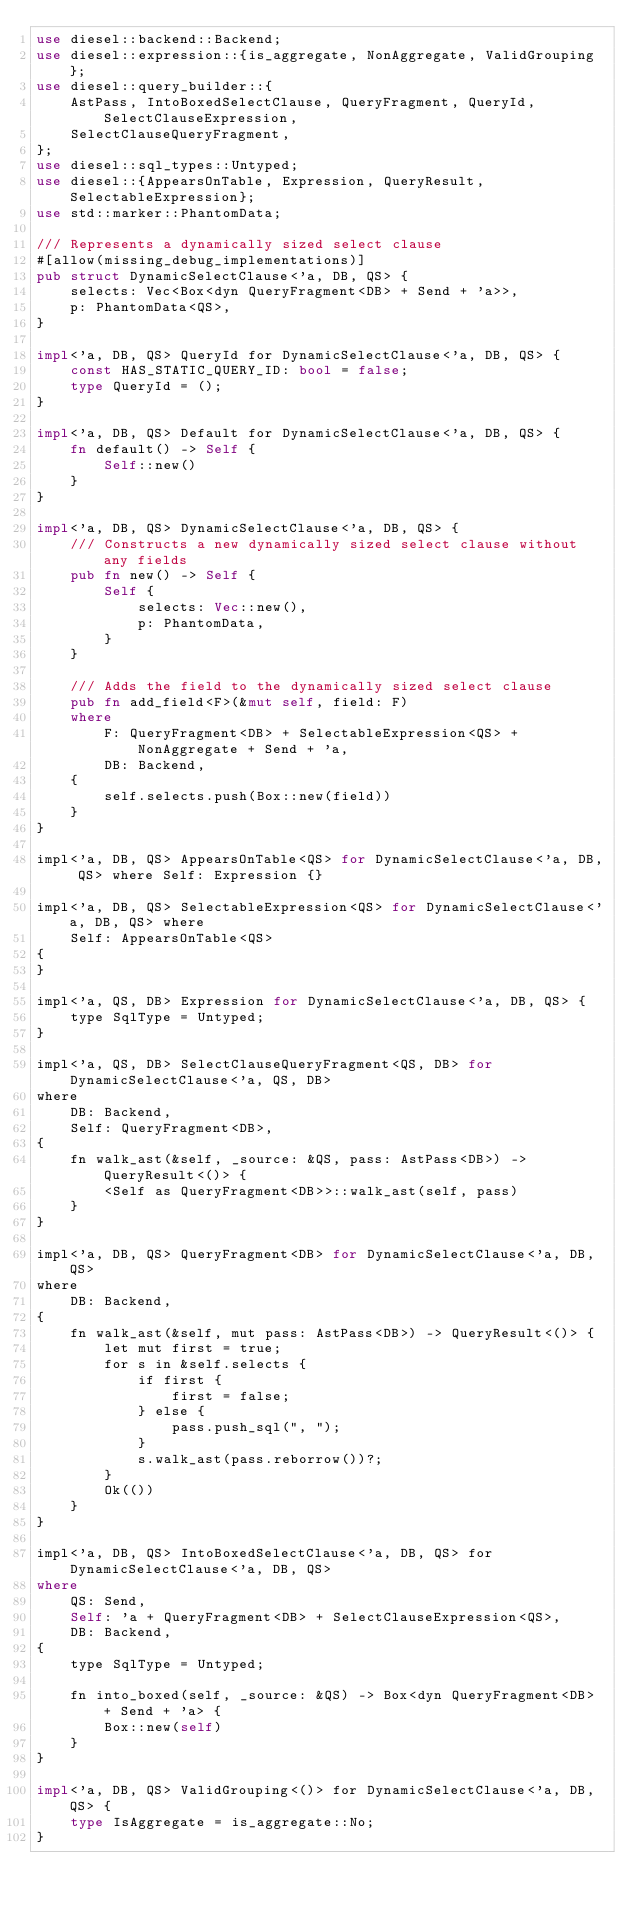<code> <loc_0><loc_0><loc_500><loc_500><_Rust_>use diesel::backend::Backend;
use diesel::expression::{is_aggregate, NonAggregate, ValidGrouping};
use diesel::query_builder::{
    AstPass, IntoBoxedSelectClause, QueryFragment, QueryId, SelectClauseExpression,
    SelectClauseQueryFragment,
};
use diesel::sql_types::Untyped;
use diesel::{AppearsOnTable, Expression, QueryResult, SelectableExpression};
use std::marker::PhantomData;

/// Represents a dynamically sized select clause
#[allow(missing_debug_implementations)]
pub struct DynamicSelectClause<'a, DB, QS> {
    selects: Vec<Box<dyn QueryFragment<DB> + Send + 'a>>,
    p: PhantomData<QS>,
}

impl<'a, DB, QS> QueryId for DynamicSelectClause<'a, DB, QS> {
    const HAS_STATIC_QUERY_ID: bool = false;
    type QueryId = ();
}

impl<'a, DB, QS> Default for DynamicSelectClause<'a, DB, QS> {
    fn default() -> Self {
        Self::new()
    }
}

impl<'a, DB, QS> DynamicSelectClause<'a, DB, QS> {
    /// Constructs a new dynamically sized select clause without any fields
    pub fn new() -> Self {
        Self {
            selects: Vec::new(),
            p: PhantomData,
        }
    }

    /// Adds the field to the dynamically sized select clause
    pub fn add_field<F>(&mut self, field: F)
    where
        F: QueryFragment<DB> + SelectableExpression<QS> + NonAggregate + Send + 'a,
        DB: Backend,
    {
        self.selects.push(Box::new(field))
    }
}

impl<'a, DB, QS> AppearsOnTable<QS> for DynamicSelectClause<'a, DB, QS> where Self: Expression {}

impl<'a, DB, QS> SelectableExpression<QS> for DynamicSelectClause<'a, DB, QS> where
    Self: AppearsOnTable<QS>
{
}

impl<'a, QS, DB> Expression for DynamicSelectClause<'a, DB, QS> {
    type SqlType = Untyped;
}

impl<'a, QS, DB> SelectClauseQueryFragment<QS, DB> for DynamicSelectClause<'a, QS, DB>
where
    DB: Backend,
    Self: QueryFragment<DB>,
{
    fn walk_ast(&self, _source: &QS, pass: AstPass<DB>) -> QueryResult<()> {
        <Self as QueryFragment<DB>>::walk_ast(self, pass)
    }
}

impl<'a, DB, QS> QueryFragment<DB> for DynamicSelectClause<'a, DB, QS>
where
    DB: Backend,
{
    fn walk_ast(&self, mut pass: AstPass<DB>) -> QueryResult<()> {
        let mut first = true;
        for s in &self.selects {
            if first {
                first = false;
            } else {
                pass.push_sql(", ");
            }
            s.walk_ast(pass.reborrow())?;
        }
        Ok(())
    }
}

impl<'a, DB, QS> IntoBoxedSelectClause<'a, DB, QS> for DynamicSelectClause<'a, DB, QS>
where
    QS: Send,
    Self: 'a + QueryFragment<DB> + SelectClauseExpression<QS>,
    DB: Backend,
{
    type SqlType = Untyped;

    fn into_boxed(self, _source: &QS) -> Box<dyn QueryFragment<DB> + Send + 'a> {
        Box::new(self)
    }
}

impl<'a, DB, QS> ValidGrouping<()> for DynamicSelectClause<'a, DB, QS> {
    type IsAggregate = is_aggregate::No;
}
</code> 